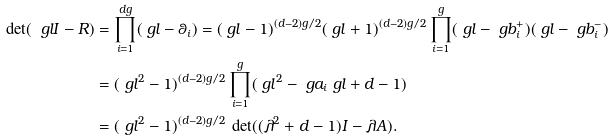Convert formula to latex. <formula><loc_0><loc_0><loc_500><loc_500>\det ( \ g l I - R ) & = \prod _ { i = 1 } ^ { d g } ( \ g l - \theta _ { i } ) = ( \ g l - 1 ) ^ { ( d - 2 ) g / 2 } ( \ g l + 1 ) ^ { ( d - 2 ) g / 2 } \prod _ { i = 1 } ^ { g } ( \ g l - \ g b _ { i } ^ { + } ) ( \ g l - \ g b _ { i } ^ { - } ) \\ & = ( \ g l ^ { 2 } - 1 ) ^ { ( d - 2 ) g / 2 } \prod _ { i = 1 } ^ { g } ( \ g l ^ { 2 } - \ g a _ { i } \ g l + d - 1 ) \\ & = ( \ g l ^ { 2 } - 1 ) ^ { ( d - 2 ) g / 2 } \, \det ( ( \lambda ^ { 2 } + d - 1 ) I - \lambda A ) .</formula> 